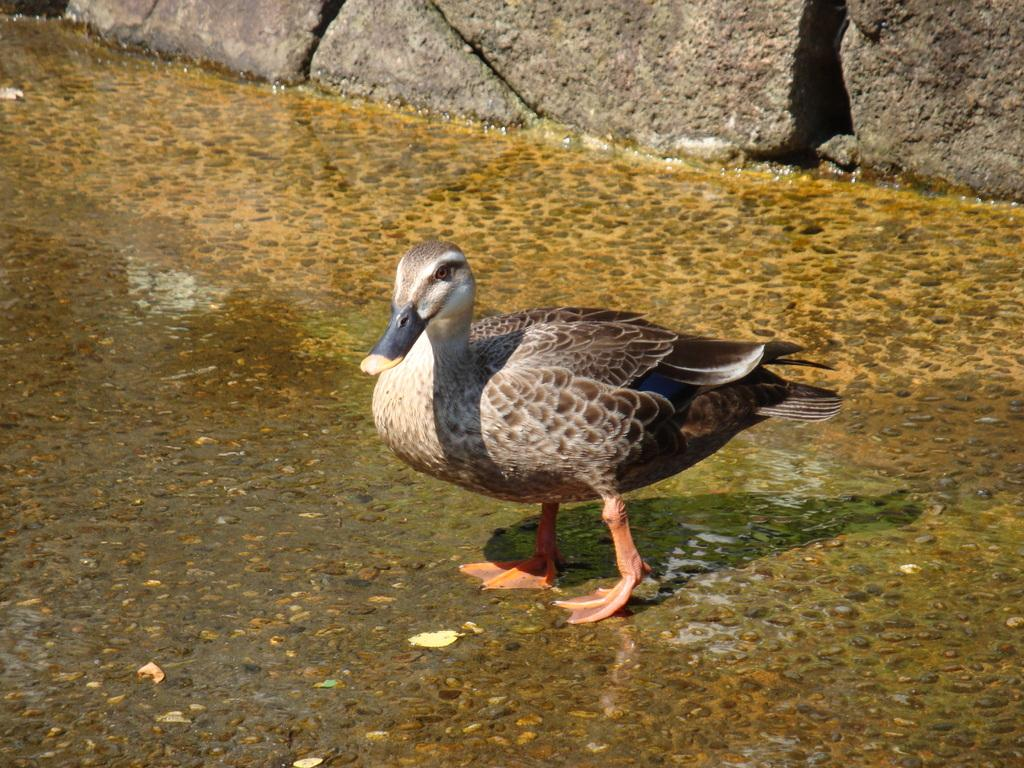What type of animal can be seen in the image? There is a bird in the image. What is visible beneath the bird? The ground is visible in the image. What other objects can be seen in the image? There are rocks in the image. What type of wool can be seen in the image? There is no wool present in the image. How many needles are visible in the image? There are no needles present in the image. 